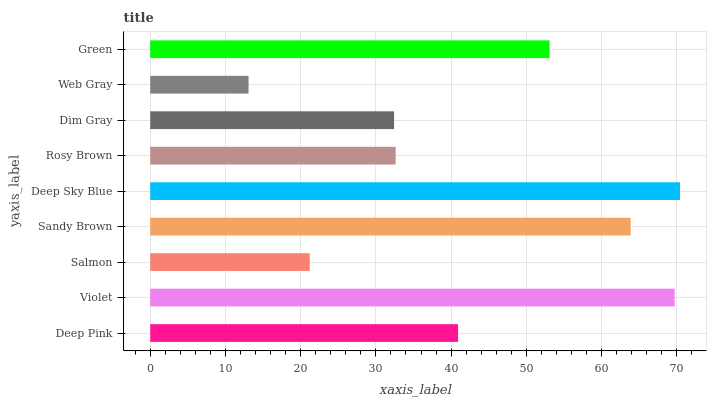Is Web Gray the minimum?
Answer yes or no. Yes. Is Deep Sky Blue the maximum?
Answer yes or no. Yes. Is Violet the minimum?
Answer yes or no. No. Is Violet the maximum?
Answer yes or no. No. Is Violet greater than Deep Pink?
Answer yes or no. Yes. Is Deep Pink less than Violet?
Answer yes or no. Yes. Is Deep Pink greater than Violet?
Answer yes or no. No. Is Violet less than Deep Pink?
Answer yes or no. No. Is Deep Pink the high median?
Answer yes or no. Yes. Is Deep Pink the low median?
Answer yes or no. Yes. Is Green the high median?
Answer yes or no. No. Is Green the low median?
Answer yes or no. No. 